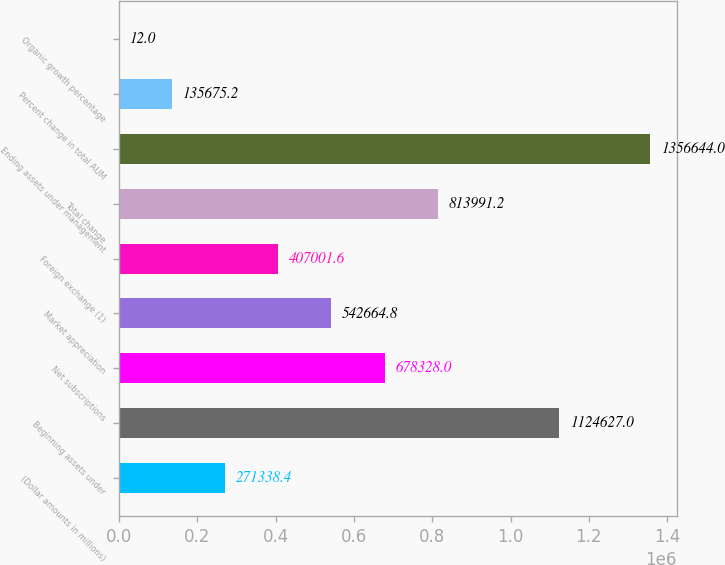Convert chart to OTSL. <chart><loc_0><loc_0><loc_500><loc_500><bar_chart><fcel>(Dollar amounts in millions)<fcel>Beginning assets under<fcel>Net subscriptions<fcel>Market appreciation<fcel>Foreign exchange (1)<fcel>Total change<fcel>Ending assets under management<fcel>Percent change in total AUM<fcel>Organic growth percentage<nl><fcel>271338<fcel>1.12463e+06<fcel>678328<fcel>542665<fcel>407002<fcel>813991<fcel>1.35664e+06<fcel>135675<fcel>12<nl></chart> 